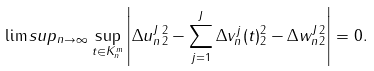Convert formula to latex. <formula><loc_0><loc_0><loc_500><loc_500>\lim s u p _ { n \rightarrow \infty } \sup _ { t \in K _ { n } ^ { m } } \left | \| \Delta u _ { n } ^ { J } \| _ { 2 } ^ { 2 } - \sum _ { j = 1 } ^ { J } \| \Delta v _ { n } ^ { j } ( t ) \| _ { 2 } ^ { 2 } - \| \Delta w _ { n } ^ { J } \| _ { 2 } ^ { 2 } \right | = 0 .</formula> 